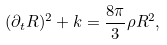<formula> <loc_0><loc_0><loc_500><loc_500>( \partial _ { t } R ) ^ { 2 } + k = \frac { 8 \pi } { 3 } \rho R ^ { 2 } ,</formula> 